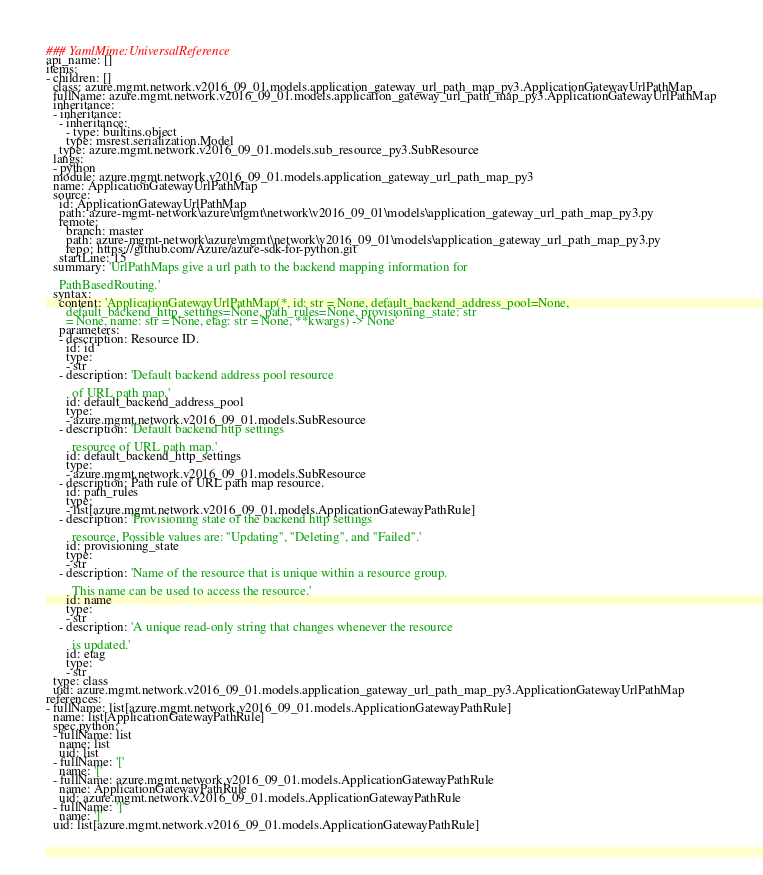<code> <loc_0><loc_0><loc_500><loc_500><_YAML_>### YamlMime:UniversalReference
api_name: []
items:
- children: []
  class: azure.mgmt.network.v2016_09_01.models.application_gateway_url_path_map_py3.ApplicationGatewayUrlPathMap
  fullName: azure.mgmt.network.v2016_09_01.models.application_gateway_url_path_map_py3.ApplicationGatewayUrlPathMap
  inheritance:
  - inheritance:
    - inheritance:
      - type: builtins.object
      type: msrest.serialization.Model
    type: azure.mgmt.network.v2016_09_01.models.sub_resource_py3.SubResource
  langs:
  - python
  module: azure.mgmt.network.v2016_09_01.models.application_gateway_url_path_map_py3
  name: ApplicationGatewayUrlPathMap
  source:
    id: ApplicationGatewayUrlPathMap
    path: azure-mgmt-network\azure\mgmt\network\v2016_09_01\models\application_gateway_url_path_map_py3.py
    remote:
      branch: master
      path: azure-mgmt-network\azure\mgmt\network\v2016_09_01\models\application_gateway_url_path_map_py3.py
      repo: https://github.com/Azure/azure-sdk-for-python.git
    startLine: 15
  summary: 'UrlPathMaps give a url path to the backend mapping information for

    PathBasedRouting.'
  syntax:
    content: 'ApplicationGatewayUrlPathMap(*, id: str = None, default_backend_address_pool=None,
      default_backend_http_settings=None, path_rules=None, provisioning_state: str
      = None, name: str = None, etag: str = None, **kwargs) -> None'
    parameters:
    - description: Resource ID.
      id: id
      type:
      - str
    - description: 'Default backend address pool resource

        of URL path map.'
      id: default_backend_address_pool
      type:
      - azure.mgmt.network.v2016_09_01.models.SubResource
    - description: 'Default backend http settings

        resource of URL path map.'
      id: default_backend_http_settings
      type:
      - azure.mgmt.network.v2016_09_01.models.SubResource
    - description: Path rule of URL path map resource.
      id: path_rules
      type:
      - list[azure.mgmt.network.v2016_09_01.models.ApplicationGatewayPathRule]
    - description: 'Provisioning state of the backend http settings

        resource. Possible values are: ''Updating'', ''Deleting'', and ''Failed''.'
      id: provisioning_state
      type:
      - str
    - description: 'Name of the resource that is unique within a resource group.

        This name can be used to access the resource.'
      id: name
      type:
      - str
    - description: 'A unique read-only string that changes whenever the resource

        is updated.'
      id: etag
      type:
      - str
  type: class
  uid: azure.mgmt.network.v2016_09_01.models.application_gateway_url_path_map_py3.ApplicationGatewayUrlPathMap
references:
- fullName: list[azure.mgmt.network.v2016_09_01.models.ApplicationGatewayPathRule]
  name: list[ApplicationGatewayPathRule]
  spec.python:
  - fullName: list
    name: list
    uid: list
  - fullName: '['
    name: '['
  - fullName: azure.mgmt.network.v2016_09_01.models.ApplicationGatewayPathRule
    name: ApplicationGatewayPathRule
    uid: azure.mgmt.network.v2016_09_01.models.ApplicationGatewayPathRule
  - fullName: ']'
    name: ']'
  uid: list[azure.mgmt.network.v2016_09_01.models.ApplicationGatewayPathRule]
</code> 